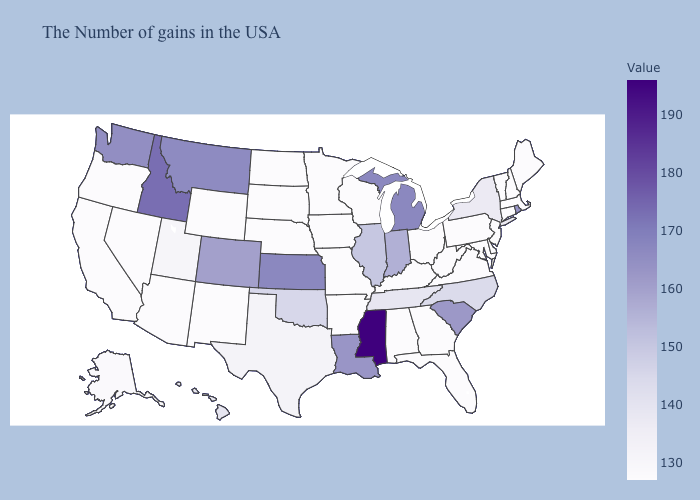Does Michigan have a higher value than Iowa?
Quick response, please. Yes. Which states have the lowest value in the MidWest?
Quick response, please. Ohio, Wisconsin, Missouri, Minnesota, Iowa, Nebraska, South Dakota, North Dakota. Does Oregon have a higher value than New York?
Answer briefly. No. Which states have the lowest value in the MidWest?
Write a very short answer. Ohio, Wisconsin, Missouri, Minnesota, Iowa, Nebraska, South Dakota, North Dakota. Does North Carolina have a higher value than Washington?
Write a very short answer. No. Which states have the highest value in the USA?
Short answer required. Mississippi. Does Hawaii have the lowest value in the West?
Keep it brief. No. 